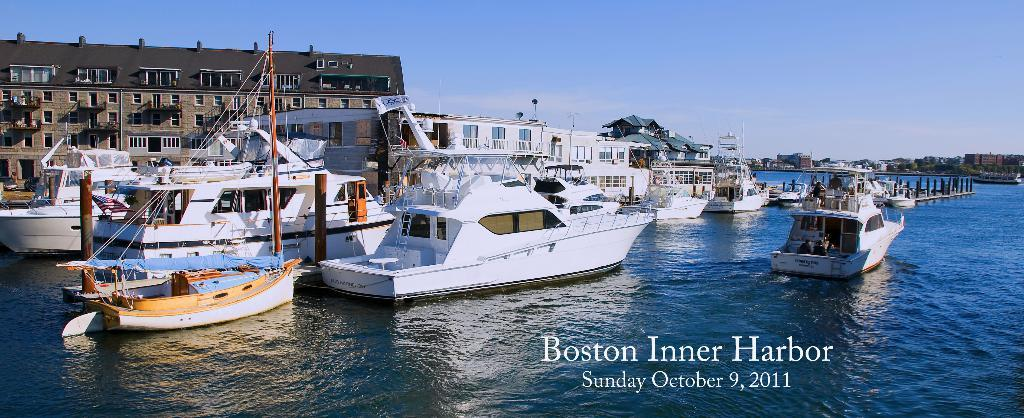What is the main subject of the image? The main subject of the image is ships. Where are the ships located? The ships are on the ocean. What can be seen in the background of the image? In the background of the image, there are poles, at least one building, vehicles, trees, water, ships, and the sky. How many ships can be seen in the background? There are ships visible in the background of the image. What is the condition of the sky in the image? The sky is visible in the background of the image, and there are clouds present. What type of event is taking place in the image? There is no indication of an event taking place in the image; it simply shows ships on the ocean and various elements in the background. How many arms can be seen on the ships in the image? There are no arms visible on the ships in the image, as ships do not have arms. 